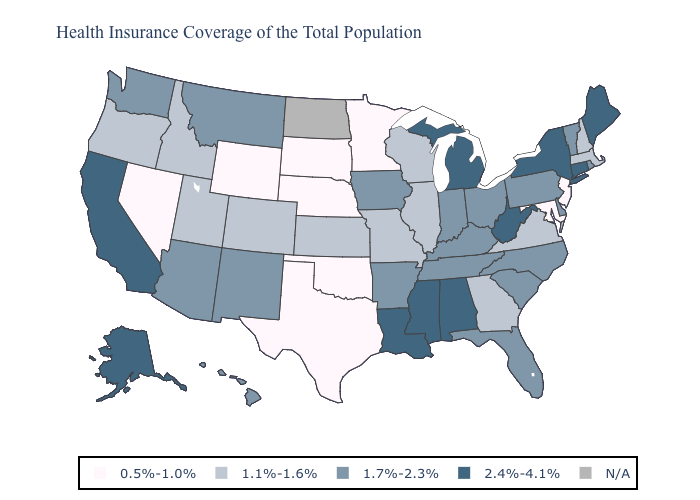What is the value of Louisiana?
Keep it brief. 2.4%-4.1%. Does the first symbol in the legend represent the smallest category?
Be succinct. Yes. Name the states that have a value in the range 0.5%-1.0%?
Concise answer only. Maryland, Minnesota, Nebraska, Nevada, New Jersey, Oklahoma, South Dakota, Texas, Wyoming. What is the lowest value in the West?
Write a very short answer. 0.5%-1.0%. Which states hav the highest value in the Northeast?
Short answer required. Connecticut, Maine, New York. How many symbols are there in the legend?
Answer briefly. 5. What is the value of Illinois?
Give a very brief answer. 1.1%-1.6%. What is the value of Rhode Island?
Give a very brief answer. 1.7%-2.3%. Does Michigan have the highest value in the MidWest?
Quick response, please. Yes. What is the value of Minnesota?
Write a very short answer. 0.5%-1.0%. Does Nevada have the lowest value in the USA?
Short answer required. Yes. What is the value of Kansas?
Concise answer only. 1.1%-1.6%. Does Wyoming have the lowest value in the West?
Be succinct. Yes. What is the value of Alabama?
Answer briefly. 2.4%-4.1%. Does Texas have the highest value in the USA?
Write a very short answer. No. 